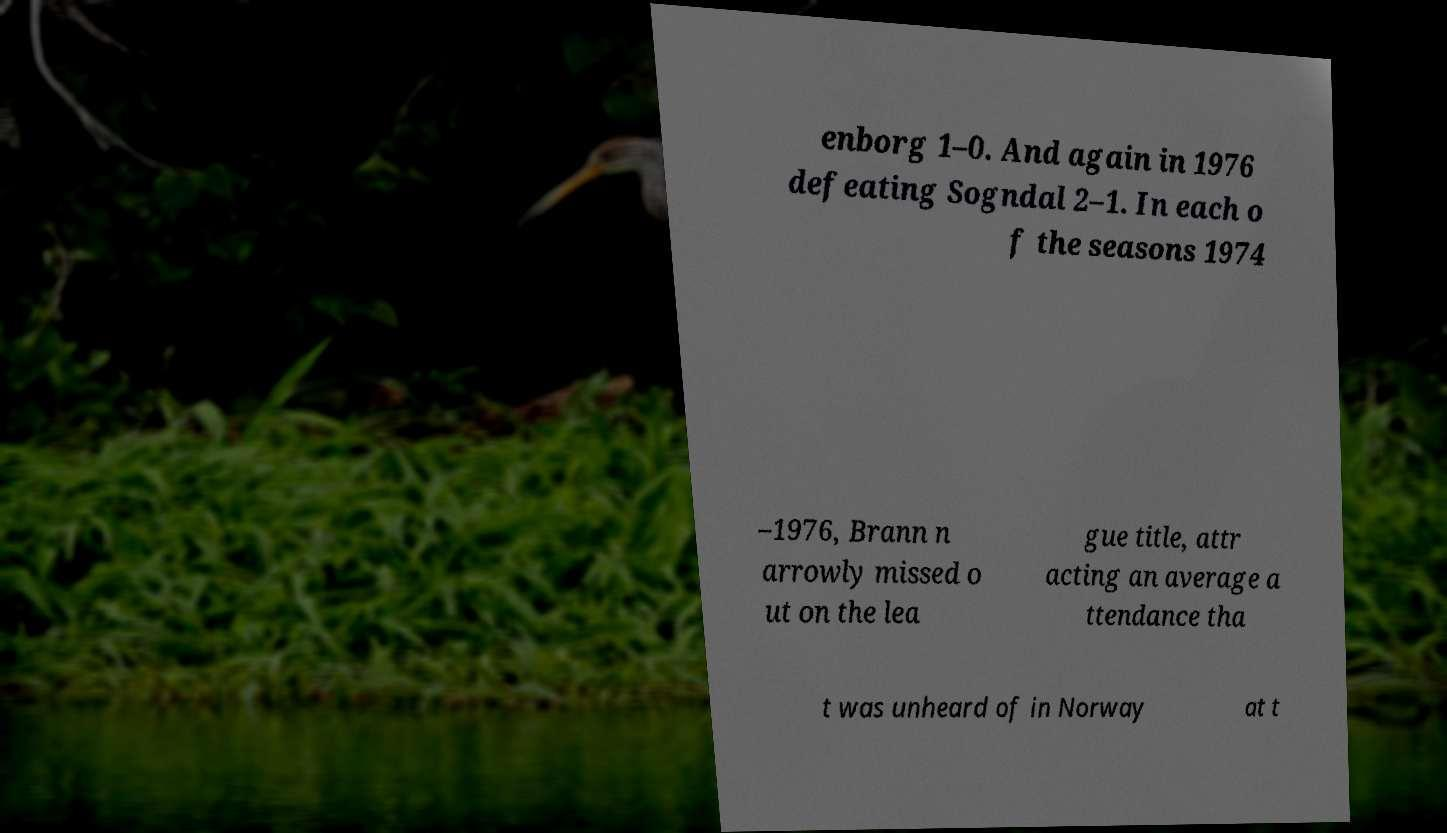Can you read and provide the text displayed in the image?This photo seems to have some interesting text. Can you extract and type it out for me? enborg 1–0. And again in 1976 defeating Sogndal 2–1. In each o f the seasons 1974 –1976, Brann n arrowly missed o ut on the lea gue title, attr acting an average a ttendance tha t was unheard of in Norway at t 